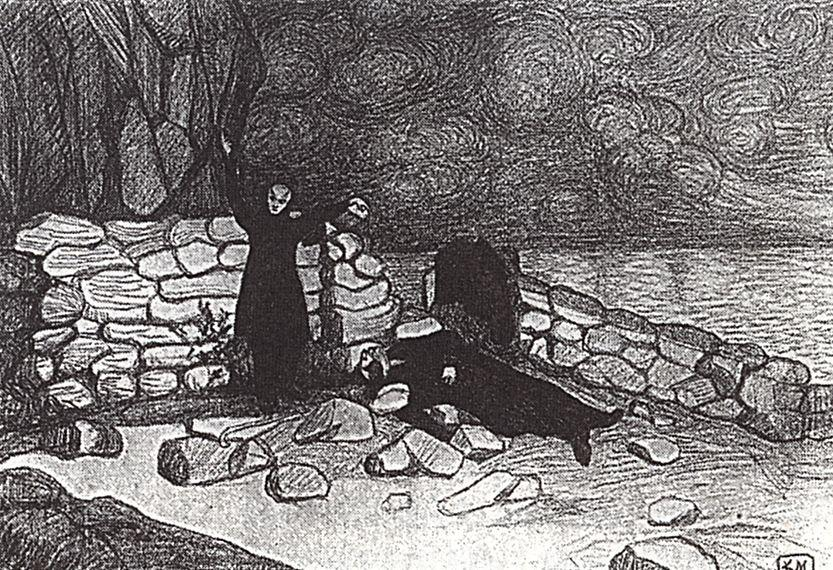What is this photo about'? The image is a black and white sketch that captures a serene landscape. The art style is impressionistic, focusing on the overall effect rather than the fine details. The scene is set on a rocky beach, where a twisted tree and a small stone building are the main subjects. The tree, with its branches reaching towards the sky, and the building, seemingly made of stone, are both dark in color, standing out against the lighter background. The beach is strewn with rocks and boulders, leading the eye towards the water in the distance. Above, the sky is filled with swirling clouds, adding a sense of movement to the otherwise still scene. The monochromatic palette enhances the dramatic contrast between the elements, creating a captivating visual narrative. 